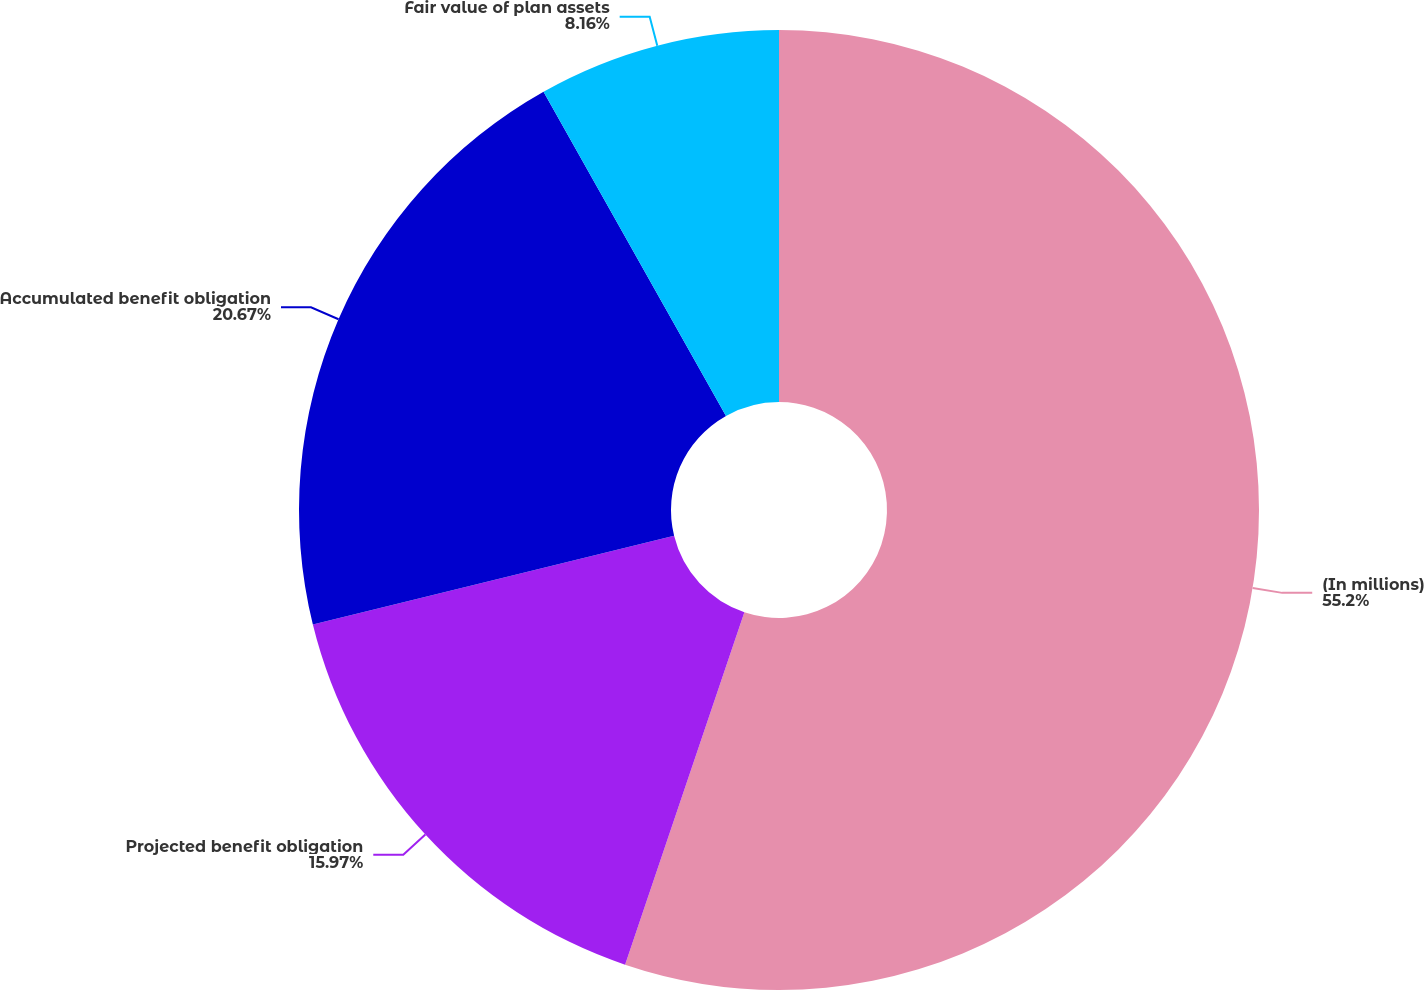Convert chart. <chart><loc_0><loc_0><loc_500><loc_500><pie_chart><fcel>(In millions)<fcel>Projected benefit obligation<fcel>Accumulated benefit obligation<fcel>Fair value of plan assets<nl><fcel>55.19%<fcel>15.97%<fcel>20.67%<fcel>8.16%<nl></chart> 